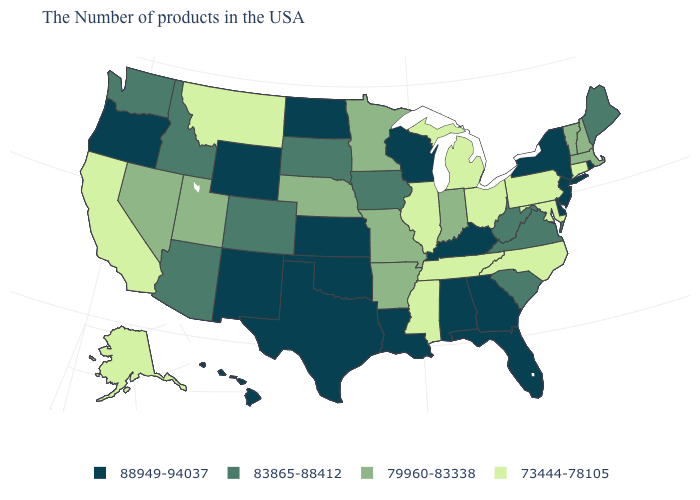Name the states that have a value in the range 73444-78105?
Write a very short answer. Connecticut, Maryland, Pennsylvania, North Carolina, Ohio, Michigan, Tennessee, Illinois, Mississippi, Montana, California, Alaska. Is the legend a continuous bar?
Quick response, please. No. Name the states that have a value in the range 73444-78105?
Quick response, please. Connecticut, Maryland, Pennsylvania, North Carolina, Ohio, Michigan, Tennessee, Illinois, Mississippi, Montana, California, Alaska. Among the states that border North Carolina , does South Carolina have the highest value?
Answer briefly. No. Does the map have missing data?
Give a very brief answer. No. What is the value of Oklahoma?
Be succinct. 88949-94037. Does Ohio have the lowest value in the USA?
Write a very short answer. Yes. Name the states that have a value in the range 88949-94037?
Short answer required. Rhode Island, New York, New Jersey, Delaware, Florida, Georgia, Kentucky, Alabama, Wisconsin, Louisiana, Kansas, Oklahoma, Texas, North Dakota, Wyoming, New Mexico, Oregon, Hawaii. Among the states that border West Virginia , does Ohio have the highest value?
Short answer required. No. Among the states that border North Dakota , which have the lowest value?
Give a very brief answer. Montana. Does Hawaii have the highest value in the West?
Concise answer only. Yes. What is the value of Georgia?
Short answer required. 88949-94037. What is the highest value in the USA?
Keep it brief. 88949-94037. Name the states that have a value in the range 88949-94037?
Answer briefly. Rhode Island, New York, New Jersey, Delaware, Florida, Georgia, Kentucky, Alabama, Wisconsin, Louisiana, Kansas, Oklahoma, Texas, North Dakota, Wyoming, New Mexico, Oregon, Hawaii. What is the value of Arizona?
Quick response, please. 83865-88412. 